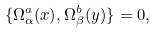Convert formula to latex. <formula><loc_0><loc_0><loc_500><loc_500>\{ \Omega ^ { a } _ { \alpha } ( x ) , \Omega ^ { b } _ { \beta } ( y ) \} = 0 ,</formula> 